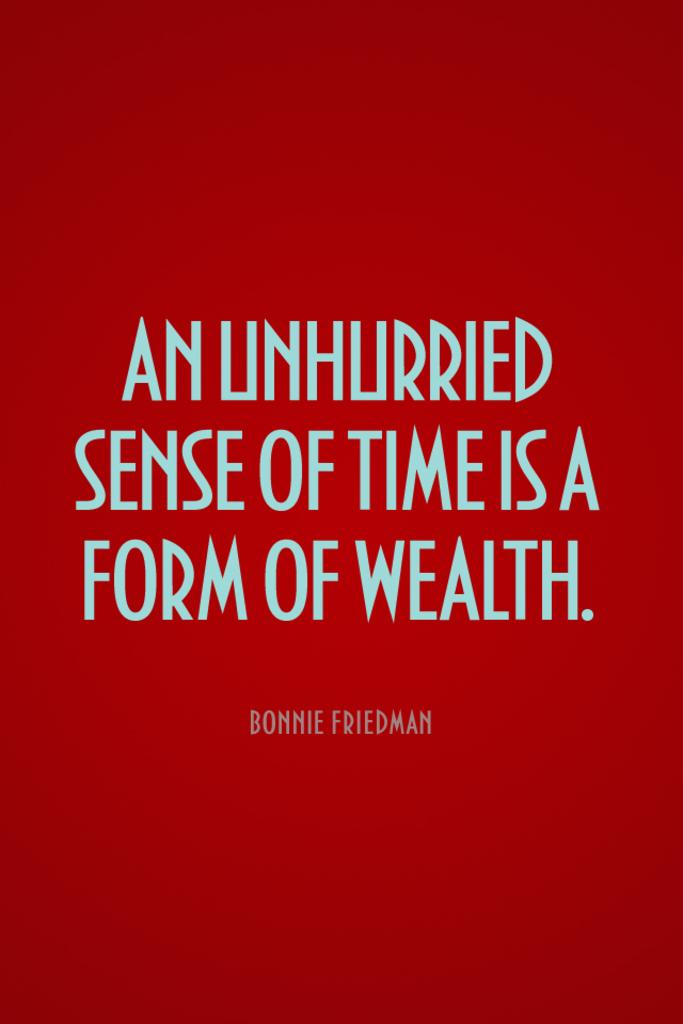Provide a one-sentence caption for the provided image. Red background with words that were written by Bonnie Friedman. 